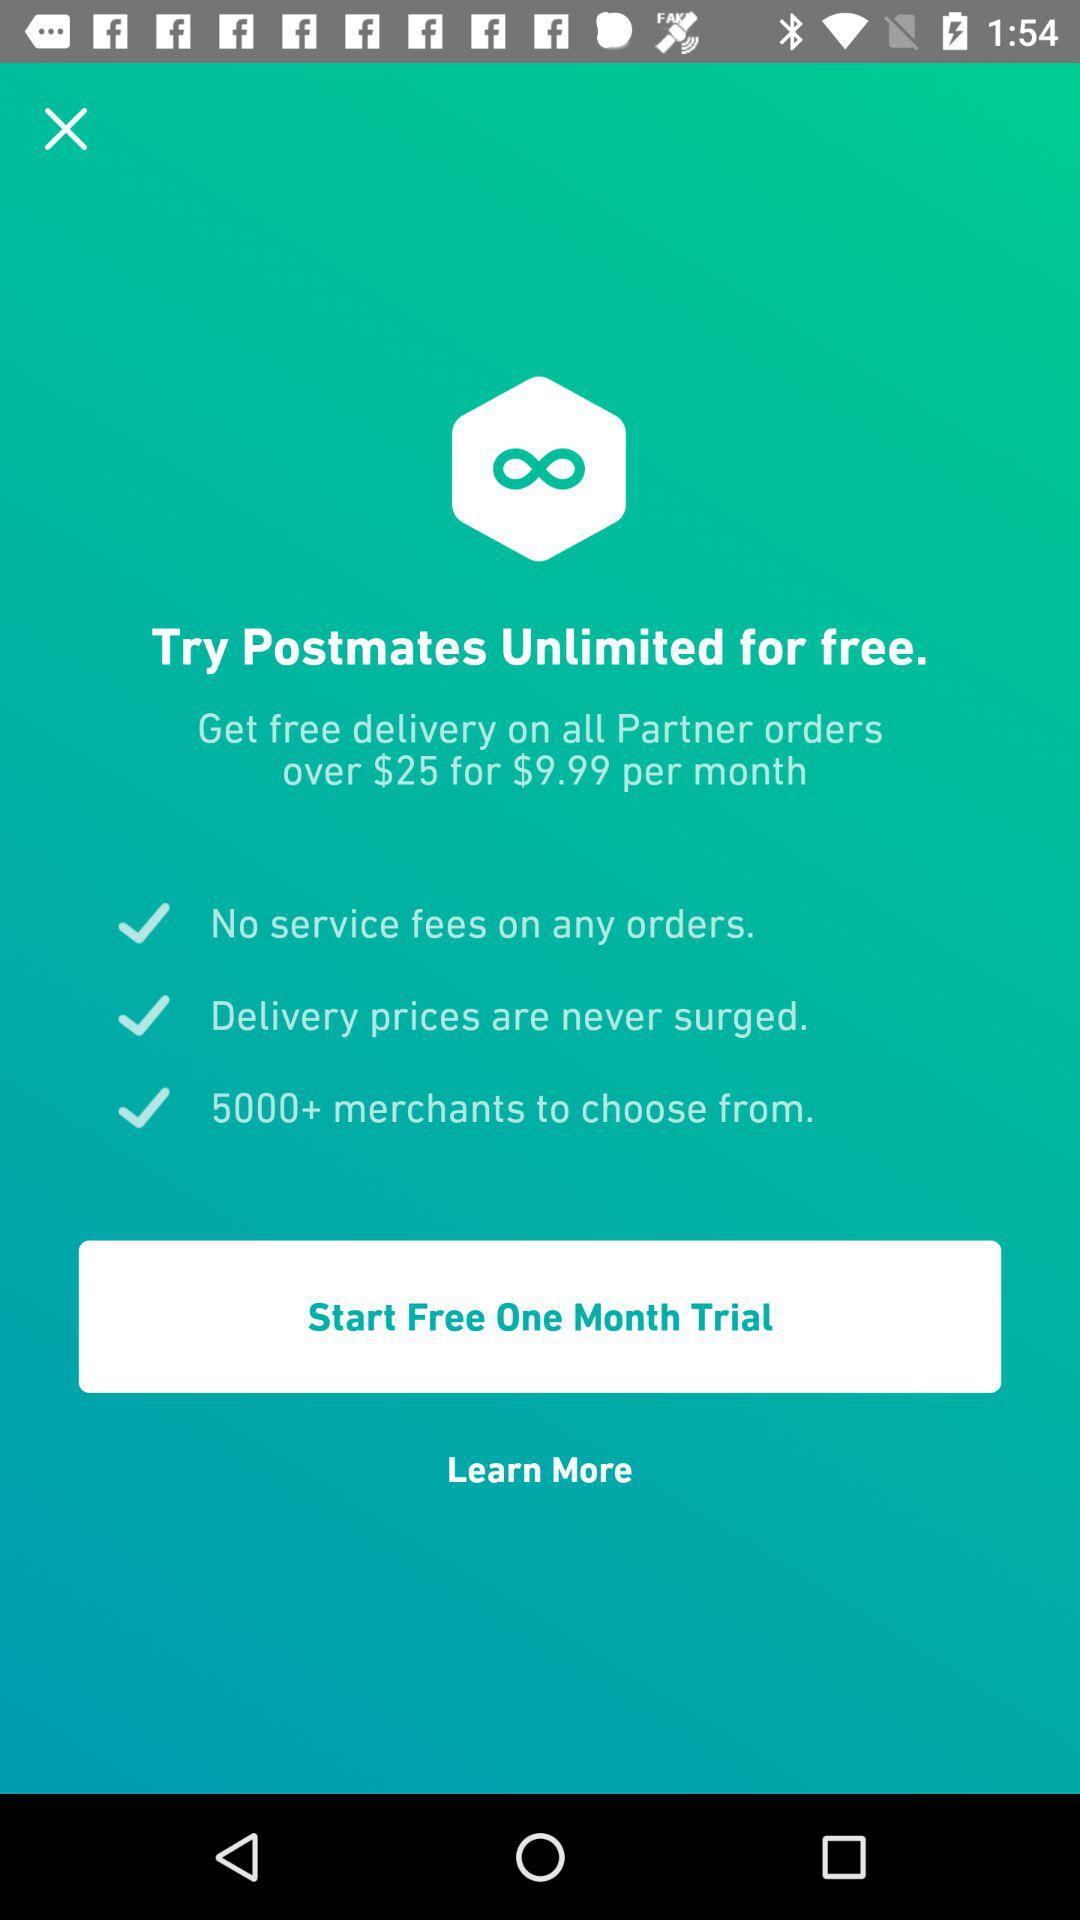How many dollars more is the monthly subscription than the one-time trial?
Answer the question using a single word or phrase. 9.99 